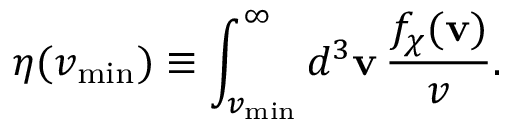Convert formula to latex. <formula><loc_0><loc_0><loc_500><loc_500>\eta ( v _ { \min } ) \equiv \int _ { v _ { \min } } ^ { \infty } d ^ { 3 } v \, \frac { f _ { \chi } ( v ) } { v } .</formula> 